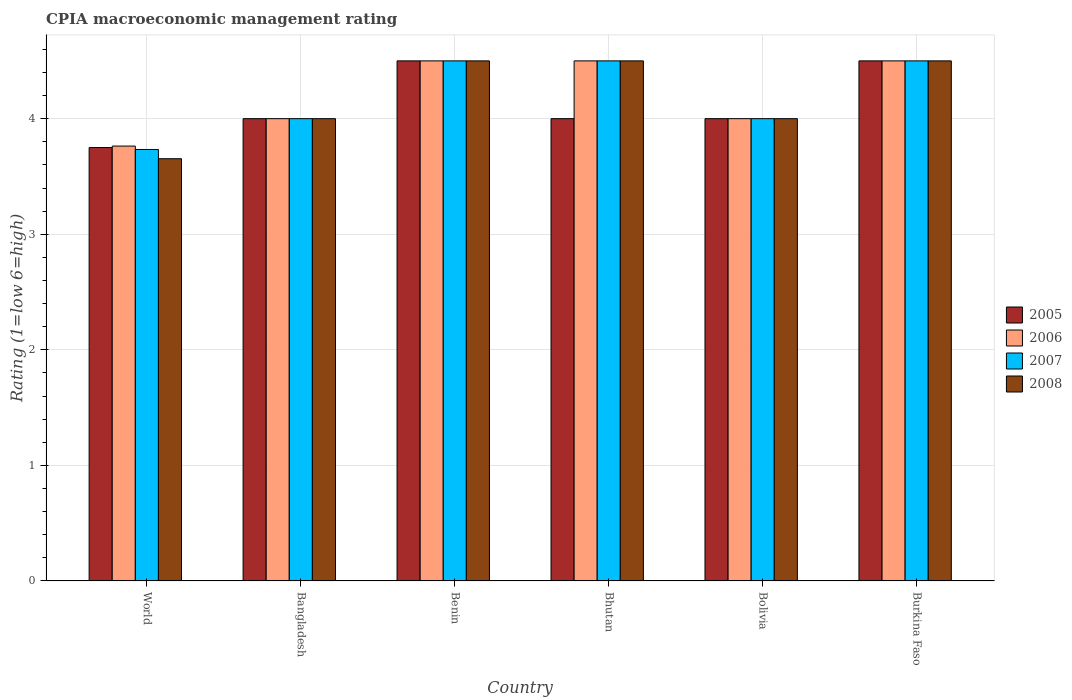How many different coloured bars are there?
Make the answer very short. 4. Are the number of bars on each tick of the X-axis equal?
Your answer should be compact. Yes. How many bars are there on the 1st tick from the left?
Offer a terse response. 4. What is the label of the 1st group of bars from the left?
Provide a short and direct response. World. Across all countries, what is the minimum CPIA rating in 2005?
Make the answer very short. 3.75. In which country was the CPIA rating in 2006 maximum?
Make the answer very short. Benin. In which country was the CPIA rating in 2006 minimum?
Your answer should be compact. World. What is the total CPIA rating in 2005 in the graph?
Provide a succinct answer. 24.75. What is the difference between the CPIA rating in 2006 in Bhutan and that in World?
Provide a short and direct response. 0.74. What is the difference between the CPIA rating in 2006 in Burkina Faso and the CPIA rating in 2008 in Bolivia?
Provide a short and direct response. 0.5. What is the average CPIA rating in 2006 per country?
Your response must be concise. 4.21. In how many countries, is the CPIA rating in 2008 greater than 2.6?
Give a very brief answer. 6. What is the ratio of the CPIA rating in 2008 in Bangladesh to that in World?
Your answer should be very brief. 1.09. Is the CPIA rating in 2005 in Bangladesh less than that in World?
Your answer should be very brief. No. Is the difference between the CPIA rating in 2006 in Bhutan and Bolivia greater than the difference between the CPIA rating in 2005 in Bhutan and Bolivia?
Keep it short and to the point. Yes. What is the difference between the highest and the second highest CPIA rating in 2005?
Give a very brief answer. 0.5. What is the difference between the highest and the lowest CPIA rating in 2008?
Ensure brevity in your answer.  0.85. Is the sum of the CPIA rating in 2006 in Bangladesh and Bhutan greater than the maximum CPIA rating in 2008 across all countries?
Offer a very short reply. Yes. Is it the case that in every country, the sum of the CPIA rating in 2005 and CPIA rating in 2008 is greater than the sum of CPIA rating in 2007 and CPIA rating in 2006?
Make the answer very short. No. What does the 1st bar from the left in Bhutan represents?
Offer a very short reply. 2005. What does the 2nd bar from the right in Bangladesh represents?
Your answer should be compact. 2007. Is it the case that in every country, the sum of the CPIA rating in 2005 and CPIA rating in 2006 is greater than the CPIA rating in 2008?
Give a very brief answer. Yes. Are all the bars in the graph horizontal?
Provide a short and direct response. No. What is the difference between two consecutive major ticks on the Y-axis?
Make the answer very short. 1. Are the values on the major ticks of Y-axis written in scientific E-notation?
Provide a short and direct response. No. Where does the legend appear in the graph?
Provide a succinct answer. Center right. How many legend labels are there?
Make the answer very short. 4. What is the title of the graph?
Your answer should be compact. CPIA macroeconomic management rating. What is the label or title of the Y-axis?
Provide a succinct answer. Rating (1=low 6=high). What is the Rating (1=low 6=high) in 2005 in World?
Keep it short and to the point. 3.75. What is the Rating (1=low 6=high) of 2006 in World?
Provide a short and direct response. 3.76. What is the Rating (1=low 6=high) of 2007 in World?
Make the answer very short. 3.73. What is the Rating (1=low 6=high) of 2008 in World?
Keep it short and to the point. 3.65. What is the Rating (1=low 6=high) of 2006 in Bangladesh?
Your response must be concise. 4. What is the Rating (1=low 6=high) in 2008 in Bangladesh?
Your answer should be very brief. 4. What is the Rating (1=low 6=high) in 2006 in Benin?
Give a very brief answer. 4.5. What is the Rating (1=low 6=high) of 2007 in Benin?
Make the answer very short. 4.5. What is the Rating (1=low 6=high) of 2006 in Bhutan?
Ensure brevity in your answer.  4.5. What is the Rating (1=low 6=high) in 2007 in Bhutan?
Ensure brevity in your answer.  4.5. What is the Rating (1=low 6=high) of 2008 in Bhutan?
Ensure brevity in your answer.  4.5. What is the Rating (1=low 6=high) in 2005 in Bolivia?
Provide a short and direct response. 4. What is the Rating (1=low 6=high) of 2007 in Bolivia?
Your answer should be compact. 4. What is the Rating (1=low 6=high) of 2005 in Burkina Faso?
Give a very brief answer. 4.5. Across all countries, what is the maximum Rating (1=low 6=high) in 2005?
Keep it short and to the point. 4.5. Across all countries, what is the maximum Rating (1=low 6=high) of 2006?
Your answer should be very brief. 4.5. Across all countries, what is the maximum Rating (1=low 6=high) in 2007?
Ensure brevity in your answer.  4.5. Across all countries, what is the maximum Rating (1=low 6=high) in 2008?
Give a very brief answer. 4.5. Across all countries, what is the minimum Rating (1=low 6=high) of 2005?
Offer a terse response. 3.75. Across all countries, what is the minimum Rating (1=low 6=high) of 2006?
Give a very brief answer. 3.76. Across all countries, what is the minimum Rating (1=low 6=high) in 2007?
Give a very brief answer. 3.73. Across all countries, what is the minimum Rating (1=low 6=high) in 2008?
Offer a terse response. 3.65. What is the total Rating (1=low 6=high) of 2005 in the graph?
Provide a succinct answer. 24.75. What is the total Rating (1=low 6=high) in 2006 in the graph?
Your answer should be very brief. 25.26. What is the total Rating (1=low 6=high) in 2007 in the graph?
Offer a terse response. 25.23. What is the total Rating (1=low 6=high) of 2008 in the graph?
Make the answer very short. 25.15. What is the difference between the Rating (1=low 6=high) in 2006 in World and that in Bangladesh?
Offer a terse response. -0.24. What is the difference between the Rating (1=low 6=high) in 2007 in World and that in Bangladesh?
Your answer should be compact. -0.27. What is the difference between the Rating (1=low 6=high) in 2008 in World and that in Bangladesh?
Make the answer very short. -0.35. What is the difference between the Rating (1=low 6=high) in 2005 in World and that in Benin?
Give a very brief answer. -0.75. What is the difference between the Rating (1=low 6=high) of 2006 in World and that in Benin?
Your answer should be compact. -0.74. What is the difference between the Rating (1=low 6=high) in 2007 in World and that in Benin?
Offer a terse response. -0.77. What is the difference between the Rating (1=low 6=high) in 2008 in World and that in Benin?
Provide a succinct answer. -0.85. What is the difference between the Rating (1=low 6=high) in 2006 in World and that in Bhutan?
Keep it short and to the point. -0.74. What is the difference between the Rating (1=low 6=high) of 2007 in World and that in Bhutan?
Provide a succinct answer. -0.77. What is the difference between the Rating (1=low 6=high) in 2008 in World and that in Bhutan?
Keep it short and to the point. -0.85. What is the difference between the Rating (1=low 6=high) of 2006 in World and that in Bolivia?
Provide a short and direct response. -0.24. What is the difference between the Rating (1=low 6=high) in 2007 in World and that in Bolivia?
Your answer should be compact. -0.27. What is the difference between the Rating (1=low 6=high) in 2008 in World and that in Bolivia?
Your response must be concise. -0.35. What is the difference between the Rating (1=low 6=high) of 2005 in World and that in Burkina Faso?
Give a very brief answer. -0.75. What is the difference between the Rating (1=low 6=high) in 2006 in World and that in Burkina Faso?
Give a very brief answer. -0.74. What is the difference between the Rating (1=low 6=high) of 2007 in World and that in Burkina Faso?
Offer a terse response. -0.77. What is the difference between the Rating (1=low 6=high) in 2008 in World and that in Burkina Faso?
Keep it short and to the point. -0.85. What is the difference between the Rating (1=low 6=high) in 2005 in Bangladesh and that in Benin?
Give a very brief answer. -0.5. What is the difference between the Rating (1=low 6=high) in 2007 in Bangladesh and that in Benin?
Keep it short and to the point. -0.5. What is the difference between the Rating (1=low 6=high) in 2008 in Bangladesh and that in Benin?
Provide a short and direct response. -0.5. What is the difference between the Rating (1=low 6=high) of 2005 in Bangladesh and that in Bhutan?
Ensure brevity in your answer.  0. What is the difference between the Rating (1=low 6=high) in 2005 in Bangladesh and that in Bolivia?
Your answer should be very brief. 0. What is the difference between the Rating (1=low 6=high) in 2007 in Bangladesh and that in Bolivia?
Provide a short and direct response. 0. What is the difference between the Rating (1=low 6=high) in 2006 in Bangladesh and that in Burkina Faso?
Keep it short and to the point. -0.5. What is the difference between the Rating (1=low 6=high) of 2008 in Bangladesh and that in Burkina Faso?
Offer a terse response. -0.5. What is the difference between the Rating (1=low 6=high) of 2006 in Benin and that in Bhutan?
Your answer should be compact. 0. What is the difference between the Rating (1=low 6=high) of 2008 in Benin and that in Bhutan?
Keep it short and to the point. 0. What is the difference between the Rating (1=low 6=high) of 2008 in Benin and that in Bolivia?
Provide a short and direct response. 0.5. What is the difference between the Rating (1=low 6=high) of 2005 in Benin and that in Burkina Faso?
Keep it short and to the point. 0. What is the difference between the Rating (1=low 6=high) of 2006 in Benin and that in Burkina Faso?
Your response must be concise. 0. What is the difference between the Rating (1=low 6=high) of 2008 in Benin and that in Burkina Faso?
Ensure brevity in your answer.  0. What is the difference between the Rating (1=low 6=high) of 2005 in Bhutan and that in Bolivia?
Your response must be concise. 0. What is the difference between the Rating (1=low 6=high) in 2007 in Bhutan and that in Bolivia?
Make the answer very short. 0.5. What is the difference between the Rating (1=low 6=high) of 2008 in Bhutan and that in Bolivia?
Offer a very short reply. 0.5. What is the difference between the Rating (1=low 6=high) of 2005 in Bhutan and that in Burkina Faso?
Ensure brevity in your answer.  -0.5. What is the difference between the Rating (1=low 6=high) in 2008 in Bhutan and that in Burkina Faso?
Ensure brevity in your answer.  0. What is the difference between the Rating (1=low 6=high) of 2005 in Bolivia and that in Burkina Faso?
Ensure brevity in your answer.  -0.5. What is the difference between the Rating (1=low 6=high) of 2006 in Bolivia and that in Burkina Faso?
Your answer should be compact. -0.5. What is the difference between the Rating (1=low 6=high) of 2007 in Bolivia and that in Burkina Faso?
Provide a succinct answer. -0.5. What is the difference between the Rating (1=low 6=high) of 2005 in World and the Rating (1=low 6=high) of 2006 in Bangladesh?
Your answer should be compact. -0.25. What is the difference between the Rating (1=low 6=high) of 2005 in World and the Rating (1=low 6=high) of 2008 in Bangladesh?
Make the answer very short. -0.25. What is the difference between the Rating (1=low 6=high) of 2006 in World and the Rating (1=low 6=high) of 2007 in Bangladesh?
Offer a very short reply. -0.24. What is the difference between the Rating (1=low 6=high) in 2006 in World and the Rating (1=low 6=high) in 2008 in Bangladesh?
Keep it short and to the point. -0.24. What is the difference between the Rating (1=low 6=high) in 2007 in World and the Rating (1=low 6=high) in 2008 in Bangladesh?
Your answer should be compact. -0.27. What is the difference between the Rating (1=low 6=high) in 2005 in World and the Rating (1=low 6=high) in 2006 in Benin?
Your answer should be compact. -0.75. What is the difference between the Rating (1=low 6=high) in 2005 in World and the Rating (1=low 6=high) in 2007 in Benin?
Ensure brevity in your answer.  -0.75. What is the difference between the Rating (1=low 6=high) in 2005 in World and the Rating (1=low 6=high) in 2008 in Benin?
Your answer should be very brief. -0.75. What is the difference between the Rating (1=low 6=high) of 2006 in World and the Rating (1=low 6=high) of 2007 in Benin?
Your response must be concise. -0.74. What is the difference between the Rating (1=low 6=high) of 2006 in World and the Rating (1=low 6=high) of 2008 in Benin?
Your answer should be compact. -0.74. What is the difference between the Rating (1=low 6=high) of 2007 in World and the Rating (1=low 6=high) of 2008 in Benin?
Your response must be concise. -0.77. What is the difference between the Rating (1=low 6=high) of 2005 in World and the Rating (1=low 6=high) of 2006 in Bhutan?
Offer a terse response. -0.75. What is the difference between the Rating (1=low 6=high) of 2005 in World and the Rating (1=low 6=high) of 2007 in Bhutan?
Provide a short and direct response. -0.75. What is the difference between the Rating (1=low 6=high) of 2005 in World and the Rating (1=low 6=high) of 2008 in Bhutan?
Offer a terse response. -0.75. What is the difference between the Rating (1=low 6=high) in 2006 in World and the Rating (1=low 6=high) in 2007 in Bhutan?
Your answer should be very brief. -0.74. What is the difference between the Rating (1=low 6=high) of 2006 in World and the Rating (1=low 6=high) of 2008 in Bhutan?
Keep it short and to the point. -0.74. What is the difference between the Rating (1=low 6=high) of 2007 in World and the Rating (1=low 6=high) of 2008 in Bhutan?
Your answer should be very brief. -0.77. What is the difference between the Rating (1=low 6=high) of 2005 in World and the Rating (1=low 6=high) of 2006 in Bolivia?
Your answer should be compact. -0.25. What is the difference between the Rating (1=low 6=high) of 2006 in World and the Rating (1=low 6=high) of 2007 in Bolivia?
Your answer should be compact. -0.24. What is the difference between the Rating (1=low 6=high) in 2006 in World and the Rating (1=low 6=high) in 2008 in Bolivia?
Your response must be concise. -0.24. What is the difference between the Rating (1=low 6=high) of 2007 in World and the Rating (1=low 6=high) of 2008 in Bolivia?
Offer a terse response. -0.27. What is the difference between the Rating (1=low 6=high) in 2005 in World and the Rating (1=low 6=high) in 2006 in Burkina Faso?
Provide a succinct answer. -0.75. What is the difference between the Rating (1=low 6=high) of 2005 in World and the Rating (1=low 6=high) of 2007 in Burkina Faso?
Make the answer very short. -0.75. What is the difference between the Rating (1=low 6=high) of 2005 in World and the Rating (1=low 6=high) of 2008 in Burkina Faso?
Make the answer very short. -0.75. What is the difference between the Rating (1=low 6=high) in 2006 in World and the Rating (1=low 6=high) in 2007 in Burkina Faso?
Your answer should be very brief. -0.74. What is the difference between the Rating (1=low 6=high) of 2006 in World and the Rating (1=low 6=high) of 2008 in Burkina Faso?
Offer a very short reply. -0.74. What is the difference between the Rating (1=low 6=high) of 2007 in World and the Rating (1=low 6=high) of 2008 in Burkina Faso?
Your answer should be very brief. -0.77. What is the difference between the Rating (1=low 6=high) in 2005 in Bangladesh and the Rating (1=low 6=high) in 2007 in Benin?
Provide a short and direct response. -0.5. What is the difference between the Rating (1=low 6=high) of 2005 in Bangladesh and the Rating (1=low 6=high) of 2008 in Benin?
Give a very brief answer. -0.5. What is the difference between the Rating (1=low 6=high) in 2007 in Bangladesh and the Rating (1=low 6=high) in 2008 in Benin?
Give a very brief answer. -0.5. What is the difference between the Rating (1=low 6=high) of 2005 in Bangladesh and the Rating (1=low 6=high) of 2006 in Bhutan?
Your response must be concise. -0.5. What is the difference between the Rating (1=low 6=high) in 2005 in Bangladesh and the Rating (1=low 6=high) in 2007 in Bhutan?
Ensure brevity in your answer.  -0.5. What is the difference between the Rating (1=low 6=high) of 2006 in Bangladesh and the Rating (1=low 6=high) of 2007 in Bhutan?
Your response must be concise. -0.5. What is the difference between the Rating (1=low 6=high) of 2006 in Bangladesh and the Rating (1=low 6=high) of 2008 in Bhutan?
Give a very brief answer. -0.5. What is the difference between the Rating (1=low 6=high) of 2005 in Bangladesh and the Rating (1=low 6=high) of 2006 in Bolivia?
Keep it short and to the point. 0. What is the difference between the Rating (1=low 6=high) in 2005 in Bangladesh and the Rating (1=low 6=high) in 2007 in Bolivia?
Offer a very short reply. 0. What is the difference between the Rating (1=low 6=high) of 2005 in Bangladesh and the Rating (1=low 6=high) of 2008 in Bolivia?
Provide a short and direct response. 0. What is the difference between the Rating (1=low 6=high) of 2007 in Bangladesh and the Rating (1=low 6=high) of 2008 in Bolivia?
Ensure brevity in your answer.  0. What is the difference between the Rating (1=low 6=high) of 2005 in Bangladesh and the Rating (1=low 6=high) of 2007 in Burkina Faso?
Offer a very short reply. -0.5. What is the difference between the Rating (1=low 6=high) of 2006 in Bangladesh and the Rating (1=low 6=high) of 2008 in Burkina Faso?
Provide a short and direct response. -0.5. What is the difference between the Rating (1=low 6=high) of 2007 in Bangladesh and the Rating (1=low 6=high) of 2008 in Burkina Faso?
Keep it short and to the point. -0.5. What is the difference between the Rating (1=low 6=high) of 2006 in Benin and the Rating (1=low 6=high) of 2008 in Bhutan?
Make the answer very short. 0. What is the difference between the Rating (1=low 6=high) of 2005 in Benin and the Rating (1=low 6=high) of 2006 in Bolivia?
Ensure brevity in your answer.  0.5. What is the difference between the Rating (1=low 6=high) of 2006 in Benin and the Rating (1=low 6=high) of 2008 in Bolivia?
Ensure brevity in your answer.  0.5. What is the difference between the Rating (1=low 6=high) of 2007 in Benin and the Rating (1=low 6=high) of 2008 in Bolivia?
Offer a terse response. 0.5. What is the difference between the Rating (1=low 6=high) of 2005 in Benin and the Rating (1=low 6=high) of 2007 in Burkina Faso?
Offer a terse response. 0. What is the difference between the Rating (1=low 6=high) in 2005 in Benin and the Rating (1=low 6=high) in 2008 in Burkina Faso?
Your response must be concise. 0. What is the difference between the Rating (1=low 6=high) of 2006 in Benin and the Rating (1=low 6=high) of 2007 in Burkina Faso?
Provide a short and direct response. 0. What is the difference between the Rating (1=low 6=high) in 2006 in Benin and the Rating (1=low 6=high) in 2008 in Burkina Faso?
Give a very brief answer. 0. What is the difference between the Rating (1=low 6=high) of 2007 in Benin and the Rating (1=low 6=high) of 2008 in Burkina Faso?
Your answer should be very brief. 0. What is the difference between the Rating (1=low 6=high) in 2005 in Bhutan and the Rating (1=low 6=high) in 2006 in Bolivia?
Ensure brevity in your answer.  0. What is the difference between the Rating (1=low 6=high) of 2006 in Bhutan and the Rating (1=low 6=high) of 2008 in Bolivia?
Provide a short and direct response. 0.5. What is the difference between the Rating (1=low 6=high) of 2007 in Bhutan and the Rating (1=low 6=high) of 2008 in Bolivia?
Ensure brevity in your answer.  0.5. What is the difference between the Rating (1=low 6=high) in 2005 in Bhutan and the Rating (1=low 6=high) in 2006 in Burkina Faso?
Give a very brief answer. -0.5. What is the difference between the Rating (1=low 6=high) in 2006 in Bhutan and the Rating (1=low 6=high) in 2008 in Burkina Faso?
Make the answer very short. 0. What is the difference between the Rating (1=low 6=high) in 2005 in Bolivia and the Rating (1=low 6=high) in 2006 in Burkina Faso?
Offer a very short reply. -0.5. What is the difference between the Rating (1=low 6=high) of 2005 in Bolivia and the Rating (1=low 6=high) of 2007 in Burkina Faso?
Offer a very short reply. -0.5. What is the difference between the Rating (1=low 6=high) in 2005 in Bolivia and the Rating (1=low 6=high) in 2008 in Burkina Faso?
Your response must be concise. -0.5. What is the difference between the Rating (1=low 6=high) of 2006 in Bolivia and the Rating (1=low 6=high) of 2008 in Burkina Faso?
Ensure brevity in your answer.  -0.5. What is the difference between the Rating (1=low 6=high) in 2007 in Bolivia and the Rating (1=low 6=high) in 2008 in Burkina Faso?
Your answer should be very brief. -0.5. What is the average Rating (1=low 6=high) in 2005 per country?
Provide a succinct answer. 4.12. What is the average Rating (1=low 6=high) in 2006 per country?
Ensure brevity in your answer.  4.21. What is the average Rating (1=low 6=high) in 2007 per country?
Provide a short and direct response. 4.21. What is the average Rating (1=low 6=high) in 2008 per country?
Your answer should be compact. 4.19. What is the difference between the Rating (1=low 6=high) of 2005 and Rating (1=low 6=high) of 2006 in World?
Your answer should be very brief. -0.01. What is the difference between the Rating (1=low 6=high) of 2005 and Rating (1=low 6=high) of 2007 in World?
Your answer should be compact. 0.02. What is the difference between the Rating (1=low 6=high) of 2005 and Rating (1=low 6=high) of 2008 in World?
Ensure brevity in your answer.  0.1. What is the difference between the Rating (1=low 6=high) in 2006 and Rating (1=low 6=high) in 2007 in World?
Your answer should be compact. 0.03. What is the difference between the Rating (1=low 6=high) of 2006 and Rating (1=low 6=high) of 2008 in World?
Make the answer very short. 0.11. What is the difference between the Rating (1=low 6=high) in 2007 and Rating (1=low 6=high) in 2008 in World?
Keep it short and to the point. 0.08. What is the difference between the Rating (1=low 6=high) of 2005 and Rating (1=low 6=high) of 2007 in Bangladesh?
Give a very brief answer. 0. What is the difference between the Rating (1=low 6=high) in 2005 and Rating (1=low 6=high) in 2008 in Bangladesh?
Ensure brevity in your answer.  0. What is the difference between the Rating (1=low 6=high) in 2005 and Rating (1=low 6=high) in 2006 in Benin?
Provide a succinct answer. 0. What is the difference between the Rating (1=low 6=high) of 2006 and Rating (1=low 6=high) of 2008 in Benin?
Your answer should be very brief. 0. What is the difference between the Rating (1=low 6=high) in 2007 and Rating (1=low 6=high) in 2008 in Benin?
Provide a short and direct response. 0. What is the difference between the Rating (1=low 6=high) in 2005 and Rating (1=low 6=high) in 2006 in Bhutan?
Keep it short and to the point. -0.5. What is the difference between the Rating (1=low 6=high) in 2005 and Rating (1=low 6=high) in 2008 in Bhutan?
Offer a terse response. -0.5. What is the difference between the Rating (1=low 6=high) of 2007 and Rating (1=low 6=high) of 2008 in Bolivia?
Your answer should be very brief. 0. What is the difference between the Rating (1=low 6=high) of 2005 and Rating (1=low 6=high) of 2008 in Burkina Faso?
Provide a short and direct response. 0. What is the difference between the Rating (1=low 6=high) of 2006 and Rating (1=low 6=high) of 2008 in Burkina Faso?
Make the answer very short. 0. What is the ratio of the Rating (1=low 6=high) of 2005 in World to that in Bangladesh?
Offer a very short reply. 0.94. What is the ratio of the Rating (1=low 6=high) in 2006 in World to that in Bangladesh?
Provide a succinct answer. 0.94. What is the ratio of the Rating (1=low 6=high) of 2007 in World to that in Bangladesh?
Keep it short and to the point. 0.93. What is the ratio of the Rating (1=low 6=high) in 2008 in World to that in Bangladesh?
Provide a succinct answer. 0.91. What is the ratio of the Rating (1=low 6=high) of 2006 in World to that in Benin?
Your answer should be very brief. 0.84. What is the ratio of the Rating (1=low 6=high) in 2007 in World to that in Benin?
Your response must be concise. 0.83. What is the ratio of the Rating (1=low 6=high) of 2008 in World to that in Benin?
Offer a terse response. 0.81. What is the ratio of the Rating (1=low 6=high) in 2006 in World to that in Bhutan?
Offer a very short reply. 0.84. What is the ratio of the Rating (1=low 6=high) in 2007 in World to that in Bhutan?
Your answer should be very brief. 0.83. What is the ratio of the Rating (1=low 6=high) of 2008 in World to that in Bhutan?
Keep it short and to the point. 0.81. What is the ratio of the Rating (1=low 6=high) in 2006 in World to that in Bolivia?
Make the answer very short. 0.94. What is the ratio of the Rating (1=low 6=high) in 2008 in World to that in Bolivia?
Your answer should be very brief. 0.91. What is the ratio of the Rating (1=low 6=high) of 2005 in World to that in Burkina Faso?
Provide a succinct answer. 0.83. What is the ratio of the Rating (1=low 6=high) in 2006 in World to that in Burkina Faso?
Provide a short and direct response. 0.84. What is the ratio of the Rating (1=low 6=high) of 2007 in World to that in Burkina Faso?
Your answer should be very brief. 0.83. What is the ratio of the Rating (1=low 6=high) in 2008 in World to that in Burkina Faso?
Your answer should be compact. 0.81. What is the ratio of the Rating (1=low 6=high) of 2006 in Bangladesh to that in Benin?
Your response must be concise. 0.89. What is the ratio of the Rating (1=low 6=high) in 2007 in Bangladesh to that in Benin?
Give a very brief answer. 0.89. What is the ratio of the Rating (1=low 6=high) in 2005 in Bangladesh to that in Bhutan?
Offer a very short reply. 1. What is the ratio of the Rating (1=low 6=high) of 2006 in Bangladesh to that in Bhutan?
Offer a very short reply. 0.89. What is the ratio of the Rating (1=low 6=high) of 2005 in Bangladesh to that in Burkina Faso?
Your answer should be compact. 0.89. What is the ratio of the Rating (1=low 6=high) in 2007 in Bangladesh to that in Burkina Faso?
Your answer should be very brief. 0.89. What is the ratio of the Rating (1=low 6=high) of 2008 in Bangladesh to that in Burkina Faso?
Keep it short and to the point. 0.89. What is the ratio of the Rating (1=low 6=high) in 2005 in Benin to that in Bhutan?
Offer a terse response. 1.12. What is the ratio of the Rating (1=low 6=high) of 2006 in Benin to that in Bhutan?
Offer a very short reply. 1. What is the ratio of the Rating (1=low 6=high) of 2007 in Benin to that in Bhutan?
Offer a terse response. 1. What is the ratio of the Rating (1=low 6=high) in 2008 in Benin to that in Bhutan?
Give a very brief answer. 1. What is the ratio of the Rating (1=low 6=high) in 2006 in Benin to that in Bolivia?
Provide a short and direct response. 1.12. What is the ratio of the Rating (1=low 6=high) of 2005 in Benin to that in Burkina Faso?
Give a very brief answer. 1. What is the ratio of the Rating (1=low 6=high) in 2007 in Benin to that in Burkina Faso?
Give a very brief answer. 1. What is the ratio of the Rating (1=low 6=high) in 2007 in Bhutan to that in Bolivia?
Offer a very short reply. 1.12. What is the ratio of the Rating (1=low 6=high) of 2008 in Bhutan to that in Bolivia?
Give a very brief answer. 1.12. What is the ratio of the Rating (1=low 6=high) of 2006 in Bhutan to that in Burkina Faso?
Your response must be concise. 1. What is the ratio of the Rating (1=low 6=high) in 2005 in Bolivia to that in Burkina Faso?
Your answer should be compact. 0.89. What is the ratio of the Rating (1=low 6=high) in 2006 in Bolivia to that in Burkina Faso?
Your answer should be compact. 0.89. What is the ratio of the Rating (1=low 6=high) in 2007 in Bolivia to that in Burkina Faso?
Give a very brief answer. 0.89. What is the ratio of the Rating (1=low 6=high) of 2008 in Bolivia to that in Burkina Faso?
Offer a terse response. 0.89. What is the difference between the highest and the second highest Rating (1=low 6=high) in 2005?
Offer a very short reply. 0. What is the difference between the highest and the lowest Rating (1=low 6=high) of 2006?
Keep it short and to the point. 0.74. What is the difference between the highest and the lowest Rating (1=low 6=high) of 2007?
Ensure brevity in your answer.  0.77. What is the difference between the highest and the lowest Rating (1=low 6=high) in 2008?
Your answer should be compact. 0.85. 